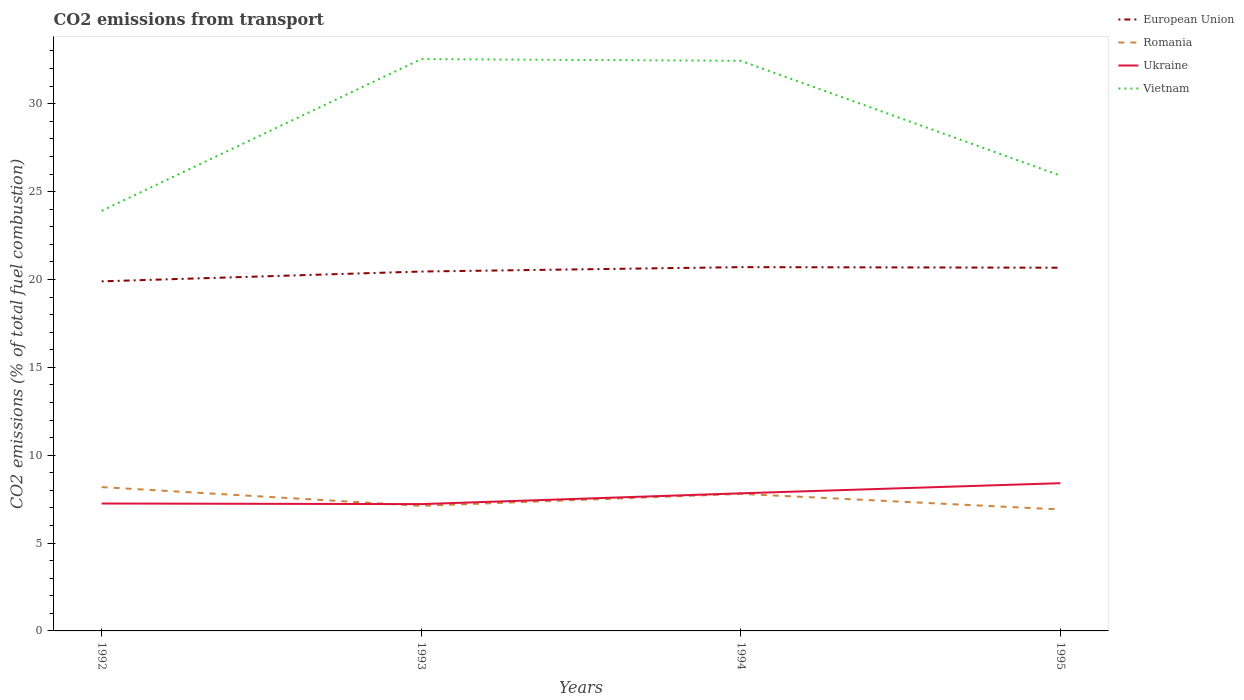How many different coloured lines are there?
Provide a succinct answer. 4. Is the number of lines equal to the number of legend labels?
Offer a terse response. Yes. Across all years, what is the maximum total CO2 emitted in Ukraine?
Make the answer very short. 7.22. What is the total total CO2 emitted in Ukraine in the graph?
Offer a terse response. -1.19. What is the difference between the highest and the second highest total CO2 emitted in Romania?
Keep it short and to the point. 1.27. Is the total CO2 emitted in Romania strictly greater than the total CO2 emitted in Ukraine over the years?
Keep it short and to the point. No. How many lines are there?
Make the answer very short. 4. Does the graph contain any zero values?
Keep it short and to the point. No. Does the graph contain grids?
Ensure brevity in your answer.  No. How many legend labels are there?
Offer a very short reply. 4. What is the title of the graph?
Provide a short and direct response. CO2 emissions from transport. Does "New Caledonia" appear as one of the legend labels in the graph?
Ensure brevity in your answer.  No. What is the label or title of the Y-axis?
Offer a very short reply. CO2 emissions (% of total fuel combustion). What is the CO2 emissions (% of total fuel combustion) of European Union in 1992?
Provide a short and direct response. 19.89. What is the CO2 emissions (% of total fuel combustion) in Romania in 1992?
Provide a short and direct response. 8.18. What is the CO2 emissions (% of total fuel combustion) of Ukraine in 1992?
Your answer should be compact. 7.25. What is the CO2 emissions (% of total fuel combustion) in Vietnam in 1992?
Your response must be concise. 23.91. What is the CO2 emissions (% of total fuel combustion) of European Union in 1993?
Your answer should be compact. 20.45. What is the CO2 emissions (% of total fuel combustion) of Romania in 1993?
Ensure brevity in your answer.  7.12. What is the CO2 emissions (% of total fuel combustion) in Ukraine in 1993?
Offer a very short reply. 7.22. What is the CO2 emissions (% of total fuel combustion) in Vietnam in 1993?
Keep it short and to the point. 32.54. What is the CO2 emissions (% of total fuel combustion) in European Union in 1994?
Provide a short and direct response. 20.7. What is the CO2 emissions (% of total fuel combustion) of Romania in 1994?
Make the answer very short. 7.8. What is the CO2 emissions (% of total fuel combustion) in Ukraine in 1994?
Provide a succinct answer. 7.83. What is the CO2 emissions (% of total fuel combustion) in Vietnam in 1994?
Offer a terse response. 32.44. What is the CO2 emissions (% of total fuel combustion) in European Union in 1995?
Your answer should be very brief. 20.67. What is the CO2 emissions (% of total fuel combustion) in Romania in 1995?
Your answer should be very brief. 6.91. What is the CO2 emissions (% of total fuel combustion) of Ukraine in 1995?
Make the answer very short. 8.41. What is the CO2 emissions (% of total fuel combustion) of Vietnam in 1995?
Your answer should be compact. 25.91. Across all years, what is the maximum CO2 emissions (% of total fuel combustion) in European Union?
Provide a succinct answer. 20.7. Across all years, what is the maximum CO2 emissions (% of total fuel combustion) in Romania?
Ensure brevity in your answer.  8.18. Across all years, what is the maximum CO2 emissions (% of total fuel combustion) in Ukraine?
Offer a very short reply. 8.41. Across all years, what is the maximum CO2 emissions (% of total fuel combustion) in Vietnam?
Keep it short and to the point. 32.54. Across all years, what is the minimum CO2 emissions (% of total fuel combustion) of European Union?
Keep it short and to the point. 19.89. Across all years, what is the minimum CO2 emissions (% of total fuel combustion) in Romania?
Give a very brief answer. 6.91. Across all years, what is the minimum CO2 emissions (% of total fuel combustion) of Ukraine?
Your response must be concise. 7.22. Across all years, what is the minimum CO2 emissions (% of total fuel combustion) in Vietnam?
Ensure brevity in your answer.  23.91. What is the total CO2 emissions (% of total fuel combustion) of European Union in the graph?
Provide a succinct answer. 81.71. What is the total CO2 emissions (% of total fuel combustion) of Romania in the graph?
Offer a terse response. 30.01. What is the total CO2 emissions (% of total fuel combustion) of Ukraine in the graph?
Ensure brevity in your answer.  30.7. What is the total CO2 emissions (% of total fuel combustion) in Vietnam in the graph?
Offer a terse response. 114.8. What is the difference between the CO2 emissions (% of total fuel combustion) of European Union in 1992 and that in 1993?
Ensure brevity in your answer.  -0.56. What is the difference between the CO2 emissions (% of total fuel combustion) in Romania in 1992 and that in 1993?
Provide a succinct answer. 1.07. What is the difference between the CO2 emissions (% of total fuel combustion) of Vietnam in 1992 and that in 1993?
Make the answer very short. -8.63. What is the difference between the CO2 emissions (% of total fuel combustion) of European Union in 1992 and that in 1994?
Provide a short and direct response. -0.81. What is the difference between the CO2 emissions (% of total fuel combustion) in Romania in 1992 and that in 1994?
Keep it short and to the point. 0.39. What is the difference between the CO2 emissions (% of total fuel combustion) of Ukraine in 1992 and that in 1994?
Ensure brevity in your answer.  -0.58. What is the difference between the CO2 emissions (% of total fuel combustion) of Vietnam in 1992 and that in 1994?
Offer a terse response. -8.54. What is the difference between the CO2 emissions (% of total fuel combustion) in European Union in 1992 and that in 1995?
Offer a very short reply. -0.78. What is the difference between the CO2 emissions (% of total fuel combustion) of Romania in 1992 and that in 1995?
Ensure brevity in your answer.  1.27. What is the difference between the CO2 emissions (% of total fuel combustion) of Ukraine in 1992 and that in 1995?
Provide a succinct answer. -1.16. What is the difference between the CO2 emissions (% of total fuel combustion) in Vietnam in 1992 and that in 1995?
Your response must be concise. -2. What is the difference between the CO2 emissions (% of total fuel combustion) of European Union in 1993 and that in 1994?
Make the answer very short. -0.25. What is the difference between the CO2 emissions (% of total fuel combustion) of Romania in 1993 and that in 1994?
Provide a succinct answer. -0.68. What is the difference between the CO2 emissions (% of total fuel combustion) in Ukraine in 1993 and that in 1994?
Give a very brief answer. -0.61. What is the difference between the CO2 emissions (% of total fuel combustion) of Vietnam in 1993 and that in 1994?
Provide a short and direct response. 0.1. What is the difference between the CO2 emissions (% of total fuel combustion) of European Union in 1993 and that in 1995?
Your answer should be very brief. -0.22. What is the difference between the CO2 emissions (% of total fuel combustion) in Romania in 1993 and that in 1995?
Provide a short and direct response. 0.21. What is the difference between the CO2 emissions (% of total fuel combustion) of Ukraine in 1993 and that in 1995?
Offer a terse response. -1.19. What is the difference between the CO2 emissions (% of total fuel combustion) of Vietnam in 1993 and that in 1995?
Your response must be concise. 6.63. What is the difference between the CO2 emissions (% of total fuel combustion) in European Union in 1994 and that in 1995?
Offer a terse response. 0.03. What is the difference between the CO2 emissions (% of total fuel combustion) in Romania in 1994 and that in 1995?
Ensure brevity in your answer.  0.89. What is the difference between the CO2 emissions (% of total fuel combustion) in Ukraine in 1994 and that in 1995?
Make the answer very short. -0.58. What is the difference between the CO2 emissions (% of total fuel combustion) of Vietnam in 1994 and that in 1995?
Provide a succinct answer. 6.53. What is the difference between the CO2 emissions (% of total fuel combustion) in European Union in 1992 and the CO2 emissions (% of total fuel combustion) in Romania in 1993?
Your answer should be very brief. 12.77. What is the difference between the CO2 emissions (% of total fuel combustion) in European Union in 1992 and the CO2 emissions (% of total fuel combustion) in Ukraine in 1993?
Offer a very short reply. 12.68. What is the difference between the CO2 emissions (% of total fuel combustion) of European Union in 1992 and the CO2 emissions (% of total fuel combustion) of Vietnam in 1993?
Keep it short and to the point. -12.65. What is the difference between the CO2 emissions (% of total fuel combustion) of Romania in 1992 and the CO2 emissions (% of total fuel combustion) of Ukraine in 1993?
Your answer should be compact. 0.97. What is the difference between the CO2 emissions (% of total fuel combustion) of Romania in 1992 and the CO2 emissions (% of total fuel combustion) of Vietnam in 1993?
Give a very brief answer. -24.36. What is the difference between the CO2 emissions (% of total fuel combustion) in Ukraine in 1992 and the CO2 emissions (% of total fuel combustion) in Vietnam in 1993?
Your response must be concise. -25.29. What is the difference between the CO2 emissions (% of total fuel combustion) in European Union in 1992 and the CO2 emissions (% of total fuel combustion) in Romania in 1994?
Your response must be concise. 12.09. What is the difference between the CO2 emissions (% of total fuel combustion) in European Union in 1992 and the CO2 emissions (% of total fuel combustion) in Ukraine in 1994?
Provide a short and direct response. 12.06. What is the difference between the CO2 emissions (% of total fuel combustion) in European Union in 1992 and the CO2 emissions (% of total fuel combustion) in Vietnam in 1994?
Provide a short and direct response. -12.55. What is the difference between the CO2 emissions (% of total fuel combustion) in Romania in 1992 and the CO2 emissions (% of total fuel combustion) in Ukraine in 1994?
Offer a very short reply. 0.35. What is the difference between the CO2 emissions (% of total fuel combustion) in Romania in 1992 and the CO2 emissions (% of total fuel combustion) in Vietnam in 1994?
Give a very brief answer. -24.26. What is the difference between the CO2 emissions (% of total fuel combustion) of Ukraine in 1992 and the CO2 emissions (% of total fuel combustion) of Vietnam in 1994?
Your answer should be very brief. -25.19. What is the difference between the CO2 emissions (% of total fuel combustion) of European Union in 1992 and the CO2 emissions (% of total fuel combustion) of Romania in 1995?
Provide a short and direct response. 12.98. What is the difference between the CO2 emissions (% of total fuel combustion) in European Union in 1992 and the CO2 emissions (% of total fuel combustion) in Ukraine in 1995?
Offer a terse response. 11.49. What is the difference between the CO2 emissions (% of total fuel combustion) in European Union in 1992 and the CO2 emissions (% of total fuel combustion) in Vietnam in 1995?
Offer a very short reply. -6.02. What is the difference between the CO2 emissions (% of total fuel combustion) of Romania in 1992 and the CO2 emissions (% of total fuel combustion) of Ukraine in 1995?
Ensure brevity in your answer.  -0.22. What is the difference between the CO2 emissions (% of total fuel combustion) of Romania in 1992 and the CO2 emissions (% of total fuel combustion) of Vietnam in 1995?
Your answer should be compact. -17.72. What is the difference between the CO2 emissions (% of total fuel combustion) in Ukraine in 1992 and the CO2 emissions (% of total fuel combustion) in Vietnam in 1995?
Provide a succinct answer. -18.66. What is the difference between the CO2 emissions (% of total fuel combustion) in European Union in 1993 and the CO2 emissions (% of total fuel combustion) in Romania in 1994?
Keep it short and to the point. 12.65. What is the difference between the CO2 emissions (% of total fuel combustion) of European Union in 1993 and the CO2 emissions (% of total fuel combustion) of Ukraine in 1994?
Make the answer very short. 12.62. What is the difference between the CO2 emissions (% of total fuel combustion) of European Union in 1993 and the CO2 emissions (% of total fuel combustion) of Vietnam in 1994?
Provide a succinct answer. -11.99. What is the difference between the CO2 emissions (% of total fuel combustion) in Romania in 1993 and the CO2 emissions (% of total fuel combustion) in Ukraine in 1994?
Provide a succinct answer. -0.71. What is the difference between the CO2 emissions (% of total fuel combustion) in Romania in 1993 and the CO2 emissions (% of total fuel combustion) in Vietnam in 1994?
Your response must be concise. -25.33. What is the difference between the CO2 emissions (% of total fuel combustion) of Ukraine in 1993 and the CO2 emissions (% of total fuel combustion) of Vietnam in 1994?
Your response must be concise. -25.23. What is the difference between the CO2 emissions (% of total fuel combustion) of European Union in 1993 and the CO2 emissions (% of total fuel combustion) of Romania in 1995?
Provide a short and direct response. 13.54. What is the difference between the CO2 emissions (% of total fuel combustion) in European Union in 1993 and the CO2 emissions (% of total fuel combustion) in Ukraine in 1995?
Ensure brevity in your answer.  12.04. What is the difference between the CO2 emissions (% of total fuel combustion) of European Union in 1993 and the CO2 emissions (% of total fuel combustion) of Vietnam in 1995?
Keep it short and to the point. -5.46. What is the difference between the CO2 emissions (% of total fuel combustion) of Romania in 1993 and the CO2 emissions (% of total fuel combustion) of Ukraine in 1995?
Provide a short and direct response. -1.29. What is the difference between the CO2 emissions (% of total fuel combustion) of Romania in 1993 and the CO2 emissions (% of total fuel combustion) of Vietnam in 1995?
Provide a short and direct response. -18.79. What is the difference between the CO2 emissions (% of total fuel combustion) in Ukraine in 1993 and the CO2 emissions (% of total fuel combustion) in Vietnam in 1995?
Your response must be concise. -18.69. What is the difference between the CO2 emissions (% of total fuel combustion) in European Union in 1994 and the CO2 emissions (% of total fuel combustion) in Romania in 1995?
Provide a succinct answer. 13.79. What is the difference between the CO2 emissions (% of total fuel combustion) of European Union in 1994 and the CO2 emissions (% of total fuel combustion) of Ukraine in 1995?
Your answer should be very brief. 12.29. What is the difference between the CO2 emissions (% of total fuel combustion) of European Union in 1994 and the CO2 emissions (% of total fuel combustion) of Vietnam in 1995?
Your answer should be very brief. -5.21. What is the difference between the CO2 emissions (% of total fuel combustion) of Romania in 1994 and the CO2 emissions (% of total fuel combustion) of Ukraine in 1995?
Provide a short and direct response. -0.61. What is the difference between the CO2 emissions (% of total fuel combustion) in Romania in 1994 and the CO2 emissions (% of total fuel combustion) in Vietnam in 1995?
Your answer should be compact. -18.11. What is the difference between the CO2 emissions (% of total fuel combustion) of Ukraine in 1994 and the CO2 emissions (% of total fuel combustion) of Vietnam in 1995?
Give a very brief answer. -18.08. What is the average CO2 emissions (% of total fuel combustion) in European Union per year?
Keep it short and to the point. 20.43. What is the average CO2 emissions (% of total fuel combustion) of Romania per year?
Make the answer very short. 7.5. What is the average CO2 emissions (% of total fuel combustion) in Ukraine per year?
Ensure brevity in your answer.  7.68. What is the average CO2 emissions (% of total fuel combustion) of Vietnam per year?
Provide a short and direct response. 28.7. In the year 1992, what is the difference between the CO2 emissions (% of total fuel combustion) in European Union and CO2 emissions (% of total fuel combustion) in Romania?
Keep it short and to the point. 11.71. In the year 1992, what is the difference between the CO2 emissions (% of total fuel combustion) of European Union and CO2 emissions (% of total fuel combustion) of Ukraine?
Your response must be concise. 12.64. In the year 1992, what is the difference between the CO2 emissions (% of total fuel combustion) in European Union and CO2 emissions (% of total fuel combustion) in Vietnam?
Your answer should be compact. -4.01. In the year 1992, what is the difference between the CO2 emissions (% of total fuel combustion) of Romania and CO2 emissions (% of total fuel combustion) of Ukraine?
Ensure brevity in your answer.  0.93. In the year 1992, what is the difference between the CO2 emissions (% of total fuel combustion) of Romania and CO2 emissions (% of total fuel combustion) of Vietnam?
Offer a terse response. -15.72. In the year 1992, what is the difference between the CO2 emissions (% of total fuel combustion) of Ukraine and CO2 emissions (% of total fuel combustion) of Vietnam?
Keep it short and to the point. -16.66. In the year 1993, what is the difference between the CO2 emissions (% of total fuel combustion) in European Union and CO2 emissions (% of total fuel combustion) in Romania?
Provide a short and direct response. 13.33. In the year 1993, what is the difference between the CO2 emissions (% of total fuel combustion) in European Union and CO2 emissions (% of total fuel combustion) in Ukraine?
Offer a very short reply. 13.23. In the year 1993, what is the difference between the CO2 emissions (% of total fuel combustion) in European Union and CO2 emissions (% of total fuel combustion) in Vietnam?
Give a very brief answer. -12.09. In the year 1993, what is the difference between the CO2 emissions (% of total fuel combustion) of Romania and CO2 emissions (% of total fuel combustion) of Ukraine?
Your answer should be compact. -0.1. In the year 1993, what is the difference between the CO2 emissions (% of total fuel combustion) of Romania and CO2 emissions (% of total fuel combustion) of Vietnam?
Provide a short and direct response. -25.42. In the year 1993, what is the difference between the CO2 emissions (% of total fuel combustion) of Ukraine and CO2 emissions (% of total fuel combustion) of Vietnam?
Your response must be concise. -25.32. In the year 1994, what is the difference between the CO2 emissions (% of total fuel combustion) in European Union and CO2 emissions (% of total fuel combustion) in Romania?
Make the answer very short. 12.9. In the year 1994, what is the difference between the CO2 emissions (% of total fuel combustion) of European Union and CO2 emissions (% of total fuel combustion) of Ukraine?
Your response must be concise. 12.87. In the year 1994, what is the difference between the CO2 emissions (% of total fuel combustion) of European Union and CO2 emissions (% of total fuel combustion) of Vietnam?
Give a very brief answer. -11.74. In the year 1994, what is the difference between the CO2 emissions (% of total fuel combustion) in Romania and CO2 emissions (% of total fuel combustion) in Ukraine?
Keep it short and to the point. -0.03. In the year 1994, what is the difference between the CO2 emissions (% of total fuel combustion) in Romania and CO2 emissions (% of total fuel combustion) in Vietnam?
Offer a very short reply. -24.64. In the year 1994, what is the difference between the CO2 emissions (% of total fuel combustion) in Ukraine and CO2 emissions (% of total fuel combustion) in Vietnam?
Keep it short and to the point. -24.61. In the year 1995, what is the difference between the CO2 emissions (% of total fuel combustion) of European Union and CO2 emissions (% of total fuel combustion) of Romania?
Offer a very short reply. 13.76. In the year 1995, what is the difference between the CO2 emissions (% of total fuel combustion) of European Union and CO2 emissions (% of total fuel combustion) of Ukraine?
Provide a succinct answer. 12.26. In the year 1995, what is the difference between the CO2 emissions (% of total fuel combustion) of European Union and CO2 emissions (% of total fuel combustion) of Vietnam?
Offer a terse response. -5.24. In the year 1995, what is the difference between the CO2 emissions (% of total fuel combustion) in Romania and CO2 emissions (% of total fuel combustion) in Ukraine?
Your answer should be compact. -1.5. In the year 1995, what is the difference between the CO2 emissions (% of total fuel combustion) of Romania and CO2 emissions (% of total fuel combustion) of Vietnam?
Your answer should be compact. -19. In the year 1995, what is the difference between the CO2 emissions (% of total fuel combustion) of Ukraine and CO2 emissions (% of total fuel combustion) of Vietnam?
Offer a very short reply. -17.5. What is the ratio of the CO2 emissions (% of total fuel combustion) of European Union in 1992 to that in 1993?
Offer a very short reply. 0.97. What is the ratio of the CO2 emissions (% of total fuel combustion) in Romania in 1992 to that in 1993?
Give a very brief answer. 1.15. What is the ratio of the CO2 emissions (% of total fuel combustion) in Vietnam in 1992 to that in 1993?
Give a very brief answer. 0.73. What is the ratio of the CO2 emissions (% of total fuel combustion) in Romania in 1992 to that in 1994?
Make the answer very short. 1.05. What is the ratio of the CO2 emissions (% of total fuel combustion) in Ukraine in 1992 to that in 1994?
Offer a terse response. 0.93. What is the ratio of the CO2 emissions (% of total fuel combustion) in Vietnam in 1992 to that in 1994?
Offer a terse response. 0.74. What is the ratio of the CO2 emissions (% of total fuel combustion) in European Union in 1992 to that in 1995?
Your answer should be very brief. 0.96. What is the ratio of the CO2 emissions (% of total fuel combustion) of Romania in 1992 to that in 1995?
Offer a terse response. 1.18. What is the ratio of the CO2 emissions (% of total fuel combustion) of Ukraine in 1992 to that in 1995?
Your answer should be very brief. 0.86. What is the ratio of the CO2 emissions (% of total fuel combustion) in Vietnam in 1992 to that in 1995?
Make the answer very short. 0.92. What is the ratio of the CO2 emissions (% of total fuel combustion) of European Union in 1993 to that in 1994?
Provide a short and direct response. 0.99. What is the ratio of the CO2 emissions (% of total fuel combustion) of Romania in 1993 to that in 1994?
Offer a very short reply. 0.91. What is the ratio of the CO2 emissions (% of total fuel combustion) in Ukraine in 1993 to that in 1994?
Keep it short and to the point. 0.92. What is the ratio of the CO2 emissions (% of total fuel combustion) in Vietnam in 1993 to that in 1994?
Your response must be concise. 1. What is the ratio of the CO2 emissions (% of total fuel combustion) in European Union in 1993 to that in 1995?
Your answer should be compact. 0.99. What is the ratio of the CO2 emissions (% of total fuel combustion) of Romania in 1993 to that in 1995?
Make the answer very short. 1.03. What is the ratio of the CO2 emissions (% of total fuel combustion) of Ukraine in 1993 to that in 1995?
Your answer should be very brief. 0.86. What is the ratio of the CO2 emissions (% of total fuel combustion) of Vietnam in 1993 to that in 1995?
Your response must be concise. 1.26. What is the ratio of the CO2 emissions (% of total fuel combustion) of European Union in 1994 to that in 1995?
Your answer should be very brief. 1. What is the ratio of the CO2 emissions (% of total fuel combustion) in Romania in 1994 to that in 1995?
Your response must be concise. 1.13. What is the ratio of the CO2 emissions (% of total fuel combustion) in Ukraine in 1994 to that in 1995?
Keep it short and to the point. 0.93. What is the ratio of the CO2 emissions (% of total fuel combustion) in Vietnam in 1994 to that in 1995?
Your answer should be compact. 1.25. What is the difference between the highest and the second highest CO2 emissions (% of total fuel combustion) of European Union?
Your response must be concise. 0.03. What is the difference between the highest and the second highest CO2 emissions (% of total fuel combustion) in Romania?
Your answer should be compact. 0.39. What is the difference between the highest and the second highest CO2 emissions (% of total fuel combustion) of Ukraine?
Give a very brief answer. 0.58. What is the difference between the highest and the second highest CO2 emissions (% of total fuel combustion) in Vietnam?
Make the answer very short. 0.1. What is the difference between the highest and the lowest CO2 emissions (% of total fuel combustion) in European Union?
Give a very brief answer. 0.81. What is the difference between the highest and the lowest CO2 emissions (% of total fuel combustion) in Romania?
Offer a very short reply. 1.27. What is the difference between the highest and the lowest CO2 emissions (% of total fuel combustion) of Ukraine?
Your answer should be compact. 1.19. What is the difference between the highest and the lowest CO2 emissions (% of total fuel combustion) of Vietnam?
Your answer should be compact. 8.63. 